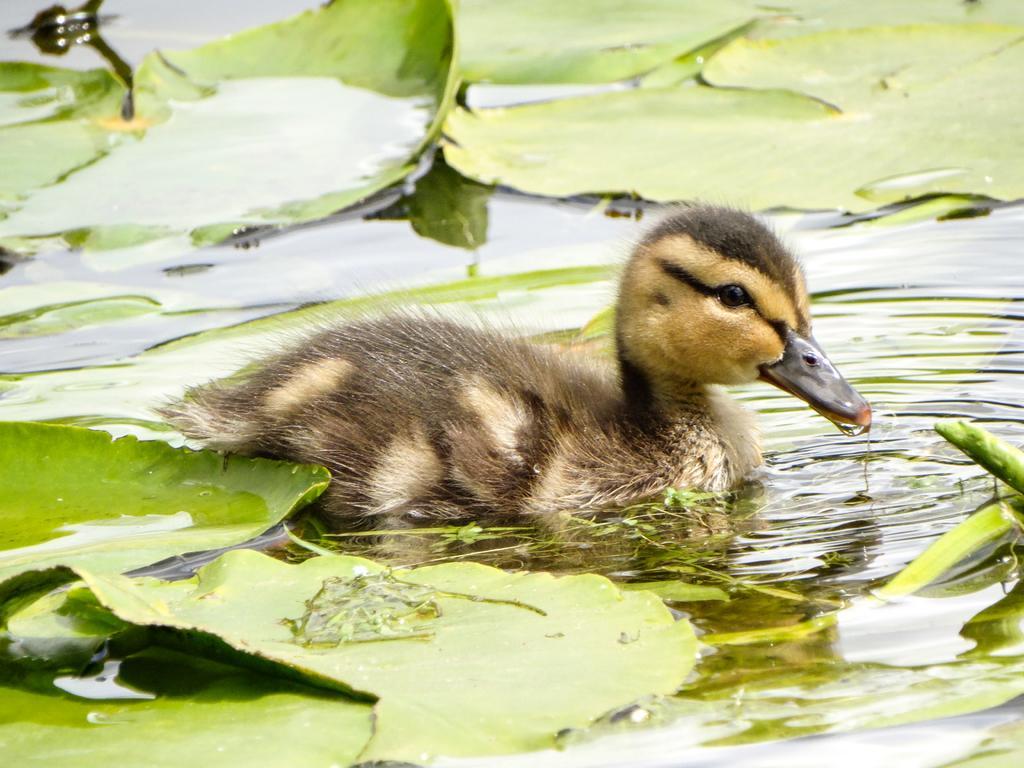Can you describe this image briefly? In this picture we can see a bird, leaves, and water. 